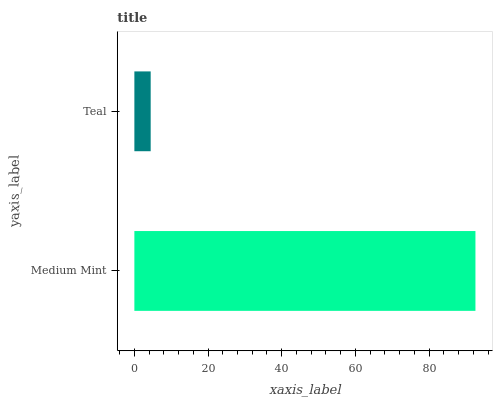Is Teal the minimum?
Answer yes or no. Yes. Is Medium Mint the maximum?
Answer yes or no. Yes. Is Teal the maximum?
Answer yes or no. No. Is Medium Mint greater than Teal?
Answer yes or no. Yes. Is Teal less than Medium Mint?
Answer yes or no. Yes. Is Teal greater than Medium Mint?
Answer yes or no. No. Is Medium Mint less than Teal?
Answer yes or no. No. Is Medium Mint the high median?
Answer yes or no. Yes. Is Teal the low median?
Answer yes or no. Yes. Is Teal the high median?
Answer yes or no. No. Is Medium Mint the low median?
Answer yes or no. No. 